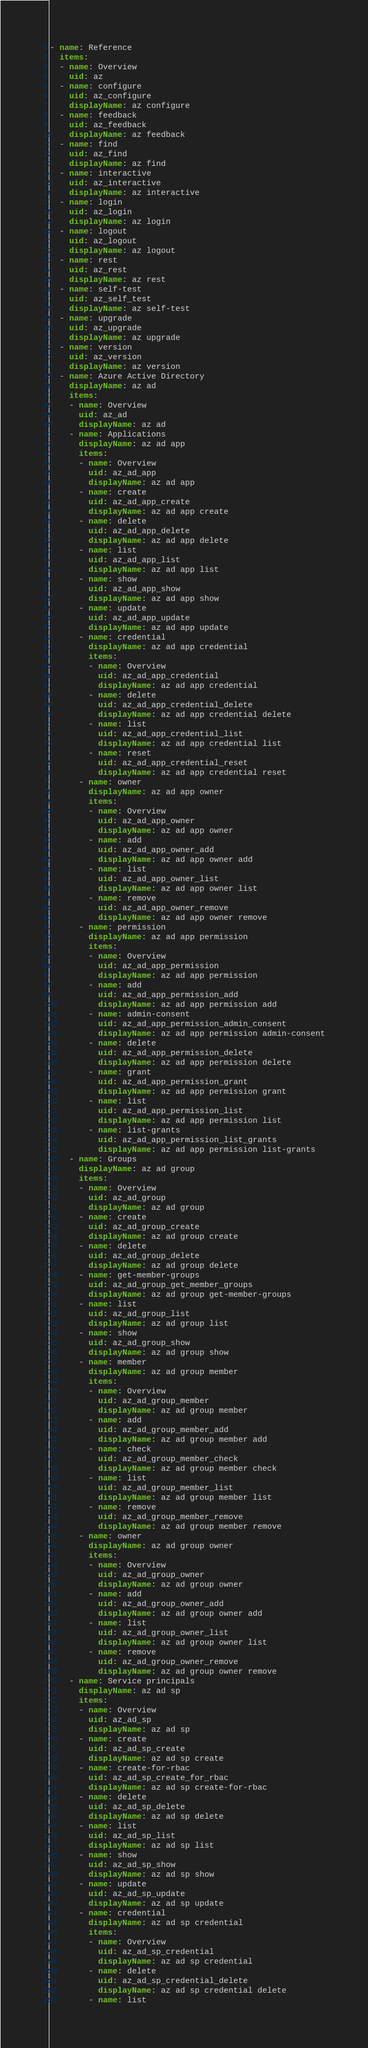<code> <loc_0><loc_0><loc_500><loc_500><_YAML_>- name: Reference
  items:
  - name: Overview
    uid: az
  - name: configure
    uid: az_configure
    displayName: az configure
  - name: feedback
    uid: az_feedback
    displayName: az feedback
  - name: find
    uid: az_find
    displayName: az find
  - name: interactive
    uid: az_interactive
    displayName: az interactive
  - name: login
    uid: az_login
    displayName: az login
  - name: logout
    uid: az_logout
    displayName: az logout
  - name: rest
    uid: az_rest
    displayName: az rest
  - name: self-test
    uid: az_self_test
    displayName: az self-test
  - name: upgrade
    uid: az_upgrade
    displayName: az upgrade
  - name: version
    uid: az_version
    displayName: az version
  - name: Azure Active Directory
    displayName: az ad
    items:
    - name: Overview
      uid: az_ad
      displayName: az ad
    - name: Applications
      displayName: az ad app
      items:
      - name: Overview
        uid: az_ad_app
        displayName: az ad app
      - name: create
        uid: az_ad_app_create
        displayName: az ad app create
      - name: delete
        uid: az_ad_app_delete
        displayName: az ad app delete
      - name: list
        uid: az_ad_app_list
        displayName: az ad app list
      - name: show
        uid: az_ad_app_show
        displayName: az ad app show
      - name: update
        uid: az_ad_app_update
        displayName: az ad app update
      - name: credential
        displayName: az ad app credential
        items:
        - name: Overview
          uid: az_ad_app_credential
          displayName: az ad app credential
        - name: delete
          uid: az_ad_app_credential_delete
          displayName: az ad app credential delete
        - name: list
          uid: az_ad_app_credential_list
          displayName: az ad app credential list
        - name: reset
          uid: az_ad_app_credential_reset
          displayName: az ad app credential reset
      - name: owner
        displayName: az ad app owner
        items:
        - name: Overview
          uid: az_ad_app_owner
          displayName: az ad app owner
        - name: add
          uid: az_ad_app_owner_add
          displayName: az ad app owner add
        - name: list
          uid: az_ad_app_owner_list
          displayName: az ad app owner list
        - name: remove
          uid: az_ad_app_owner_remove
          displayName: az ad app owner remove
      - name: permission
        displayName: az ad app permission
        items:
        - name: Overview
          uid: az_ad_app_permission
          displayName: az ad app permission
        - name: add
          uid: az_ad_app_permission_add
          displayName: az ad app permission add
        - name: admin-consent
          uid: az_ad_app_permission_admin_consent
          displayName: az ad app permission admin-consent
        - name: delete
          uid: az_ad_app_permission_delete
          displayName: az ad app permission delete
        - name: grant
          uid: az_ad_app_permission_grant
          displayName: az ad app permission grant
        - name: list
          uid: az_ad_app_permission_list
          displayName: az ad app permission list
        - name: list-grants
          uid: az_ad_app_permission_list_grants
          displayName: az ad app permission list-grants
    - name: Groups
      displayName: az ad group
      items:
      - name: Overview
        uid: az_ad_group
        displayName: az ad group
      - name: create
        uid: az_ad_group_create
        displayName: az ad group create
      - name: delete
        uid: az_ad_group_delete
        displayName: az ad group delete
      - name: get-member-groups
        uid: az_ad_group_get_member_groups
        displayName: az ad group get-member-groups
      - name: list
        uid: az_ad_group_list
        displayName: az ad group list
      - name: show
        uid: az_ad_group_show
        displayName: az ad group show
      - name: member
        displayName: az ad group member
        items:
        - name: Overview
          uid: az_ad_group_member
          displayName: az ad group member
        - name: add
          uid: az_ad_group_member_add
          displayName: az ad group member add
        - name: check
          uid: az_ad_group_member_check
          displayName: az ad group member check
        - name: list
          uid: az_ad_group_member_list
          displayName: az ad group member list
        - name: remove
          uid: az_ad_group_member_remove
          displayName: az ad group member remove
      - name: owner
        displayName: az ad group owner
        items:
        - name: Overview
          uid: az_ad_group_owner
          displayName: az ad group owner
        - name: add
          uid: az_ad_group_owner_add
          displayName: az ad group owner add
        - name: list
          uid: az_ad_group_owner_list
          displayName: az ad group owner list
        - name: remove
          uid: az_ad_group_owner_remove
          displayName: az ad group owner remove
    - name: Service principals
      displayName: az ad sp
      items:
      - name: Overview
        uid: az_ad_sp
        displayName: az ad sp
      - name: create
        uid: az_ad_sp_create
        displayName: az ad sp create
      - name: create-for-rbac
        uid: az_ad_sp_create_for_rbac
        displayName: az ad sp create-for-rbac
      - name: delete
        uid: az_ad_sp_delete
        displayName: az ad sp delete
      - name: list
        uid: az_ad_sp_list
        displayName: az ad sp list
      - name: show
        uid: az_ad_sp_show
        displayName: az ad sp show
      - name: update
        uid: az_ad_sp_update
        displayName: az ad sp update
      - name: credential
        displayName: az ad sp credential
        items:
        - name: Overview
          uid: az_ad_sp_credential
          displayName: az ad sp credential
        - name: delete
          uid: az_ad_sp_credential_delete
          displayName: az ad sp credential delete
        - name: list</code> 